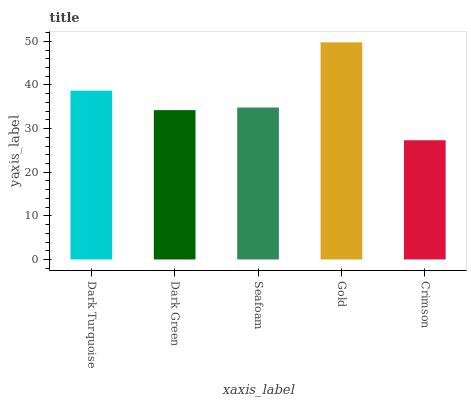Is Crimson the minimum?
Answer yes or no. Yes. Is Gold the maximum?
Answer yes or no. Yes. Is Dark Green the minimum?
Answer yes or no. No. Is Dark Green the maximum?
Answer yes or no. No. Is Dark Turquoise greater than Dark Green?
Answer yes or no. Yes. Is Dark Green less than Dark Turquoise?
Answer yes or no. Yes. Is Dark Green greater than Dark Turquoise?
Answer yes or no. No. Is Dark Turquoise less than Dark Green?
Answer yes or no. No. Is Seafoam the high median?
Answer yes or no. Yes. Is Seafoam the low median?
Answer yes or no. Yes. Is Gold the high median?
Answer yes or no. No. Is Dark Turquoise the low median?
Answer yes or no. No. 